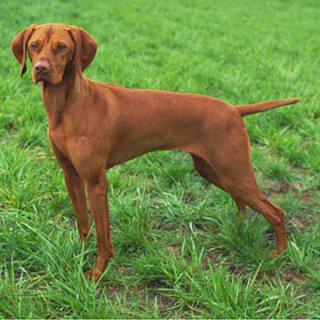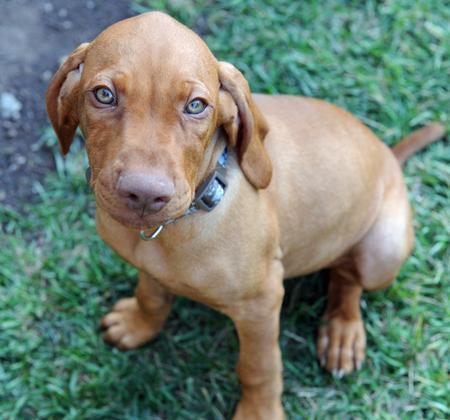The first image is the image on the left, the second image is the image on the right. Given the left and right images, does the statement "A dog has something in its mouth in the right image." hold true? Answer yes or no. No. The first image is the image on the left, the second image is the image on the right. Examine the images to the left and right. Is the description "The dog in the left image is standing on all fours on grass with its body in profile, and the dog on the right has its body turned leftward." accurate? Answer yes or no. Yes. 